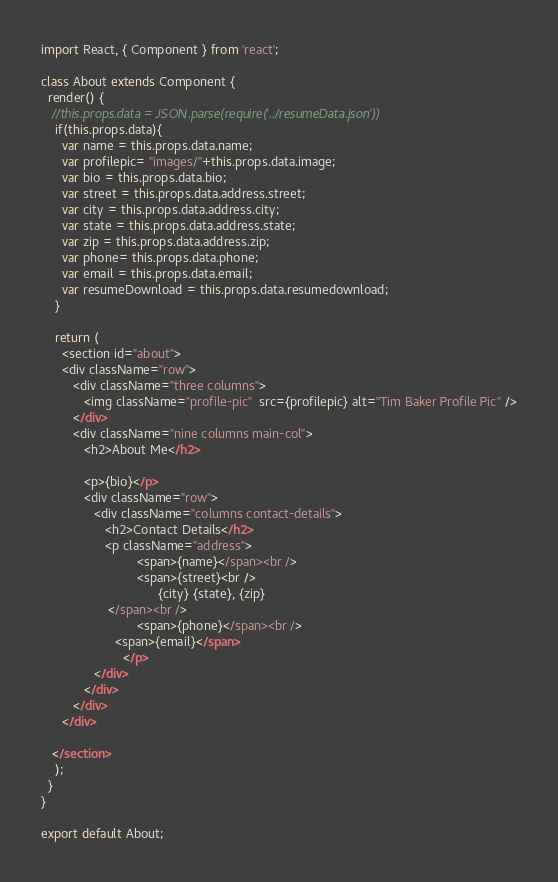<code> <loc_0><loc_0><loc_500><loc_500><_JavaScript_>import React, { Component } from 'react';

class About extends Component {
  render() {
   //this.props.data = JSON.parse(require('../resumeData.json'))
    if(this.props.data){
      var name = this.props.data.name;
      var profilepic= "images/"+this.props.data.image;
      var bio = this.props.data.bio;
      var street = this.props.data.address.street;
      var city = this.props.data.address.city;
      var state = this.props.data.address.state;
      var zip = this.props.data.address.zip;
      var phone= this.props.data.phone;
      var email = this.props.data.email;
      var resumeDownload = this.props.data.resumedownload;
    }

    return (
      <section id="about">
      <div className="row">
         <div className="three columns">
            <img className="profile-pic"  src={profilepic} alt="Tim Baker Profile Pic" />
         </div>
         <div className="nine columns main-col">
            <h2>About Me</h2>

            <p>{bio}</p>
            <div className="row">
               <div className="columns contact-details">
                  <h2>Contact Details</h2>
                  <p className="address">
						   <span>{name}</span><br />
						   <span>{street}<br />
						         {city} {state}, {zip}
                   </span><br />
						   <span>{phone}</span><br />
                     <span>{email}</span>
					   </p>
               </div>
            </div>
         </div>
      </div>

   </section>
    );
  }
}

export default About;
</code> 